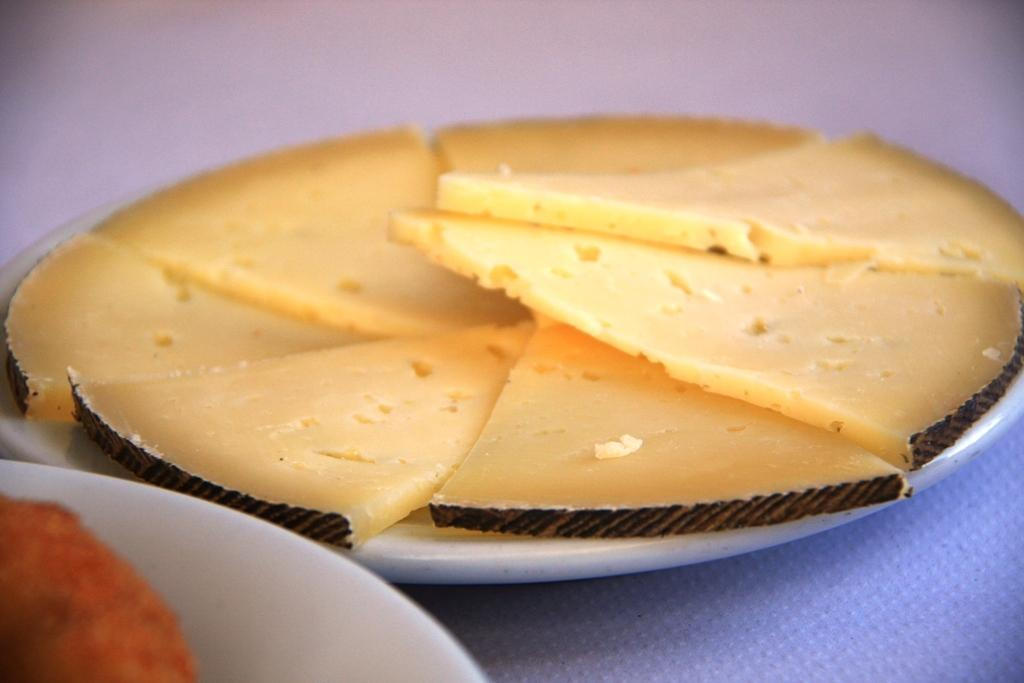What is on the plate that is visible in the image? There is food in a plate in the image. Can you describe the arrangement of the plates in the image? There is another plate on the side on a table in the image. What type of yam is growing on the wall in the image? There is no yam growing on the wall in the image; it features plates with food. What territory is depicted in the image? The image does not depict any specific territory; it simply shows plates with food on a table. 